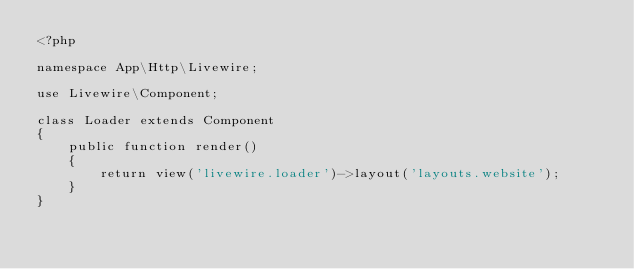<code> <loc_0><loc_0><loc_500><loc_500><_PHP_><?php

namespace App\Http\Livewire;

use Livewire\Component;

class Loader extends Component
{
    public function render()
    {
        return view('livewire.loader')->layout('layouts.website');
    }
}
</code> 